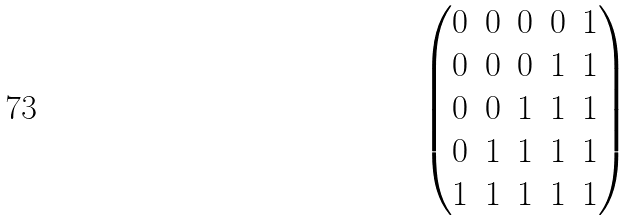Convert formula to latex. <formula><loc_0><loc_0><loc_500><loc_500>\begin{pmatrix} 0 & 0 & 0 & 0 & 1 \\ 0 & 0 & 0 & 1 & 1 \\ 0 & 0 & 1 & 1 & 1 \\ 0 & 1 & 1 & 1 & 1 \\ 1 & 1 & 1 & 1 & 1 \\ \end{pmatrix}</formula> 